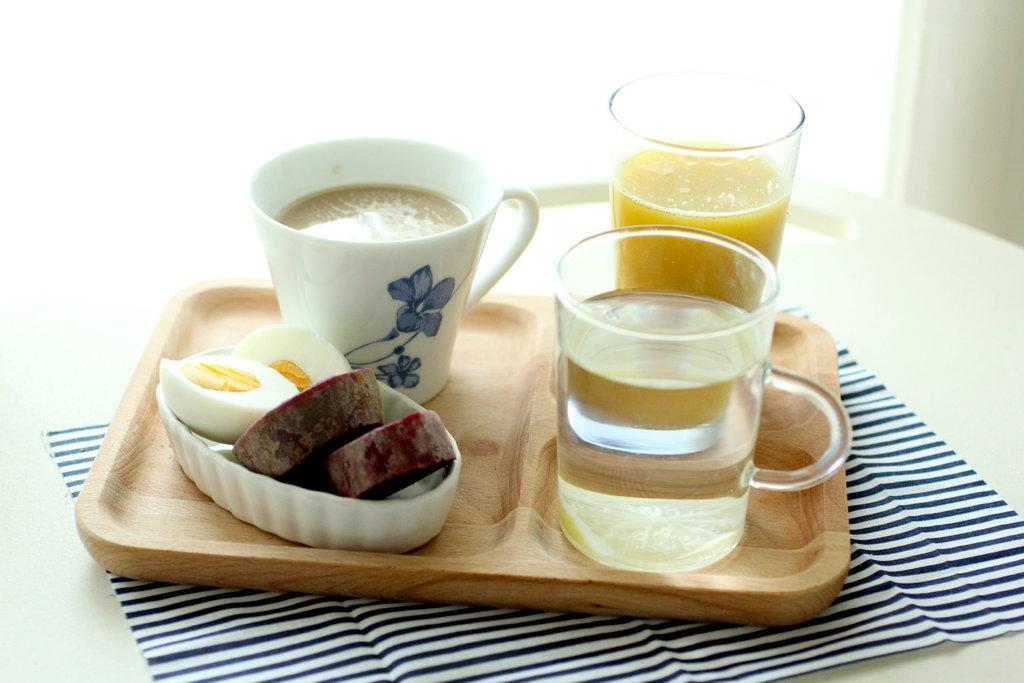How many glasses can be seen in the image? There are two glasses in the image. What else is present in the image that can hold a beverage? There is a cup with a drink in the image. What type of food is on the plate in the image? The fact does not specify the type of food on the plate, so we cannot answer that question definitively. What is the cloth used for in the image? The purpose of the cloth in the image is not specified, so we cannot answer that question definitively. How many insects are crawling on the house in the image? There is no house or insects present in the image. What color is the leg of the person in the image? There is no person or leg present in the image. 